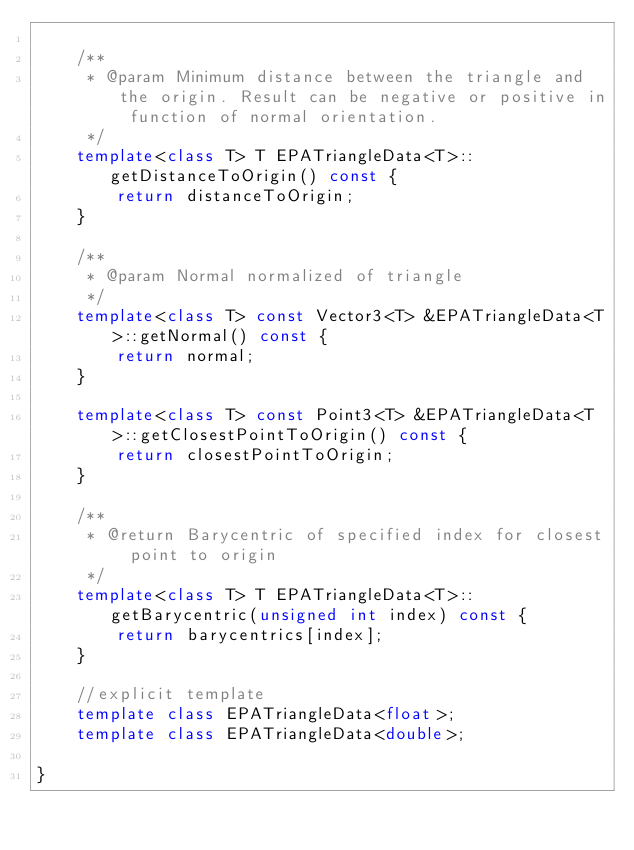<code> <loc_0><loc_0><loc_500><loc_500><_C++_>
    /**
     * @param Minimum distance between the triangle and the origin. Result can be negative or positive in function of normal orientation.
     */
    template<class T> T EPATriangleData<T>::getDistanceToOrigin() const {
        return distanceToOrigin;
    }

    /**
     * @param Normal normalized of triangle
     */
    template<class T> const Vector3<T> &EPATriangleData<T>::getNormal() const {
        return normal;
    }

    template<class T> const Point3<T> &EPATriangleData<T>::getClosestPointToOrigin() const {
        return closestPointToOrigin;
    }

    /**
     * @return Barycentric of specified index for closest point to origin
     */
    template<class T> T EPATriangleData<T>::getBarycentric(unsigned int index) const {
        return barycentrics[index];
    }

    //explicit template
    template class EPATriangleData<float>;
    template class EPATriangleData<double>;

}
</code> 